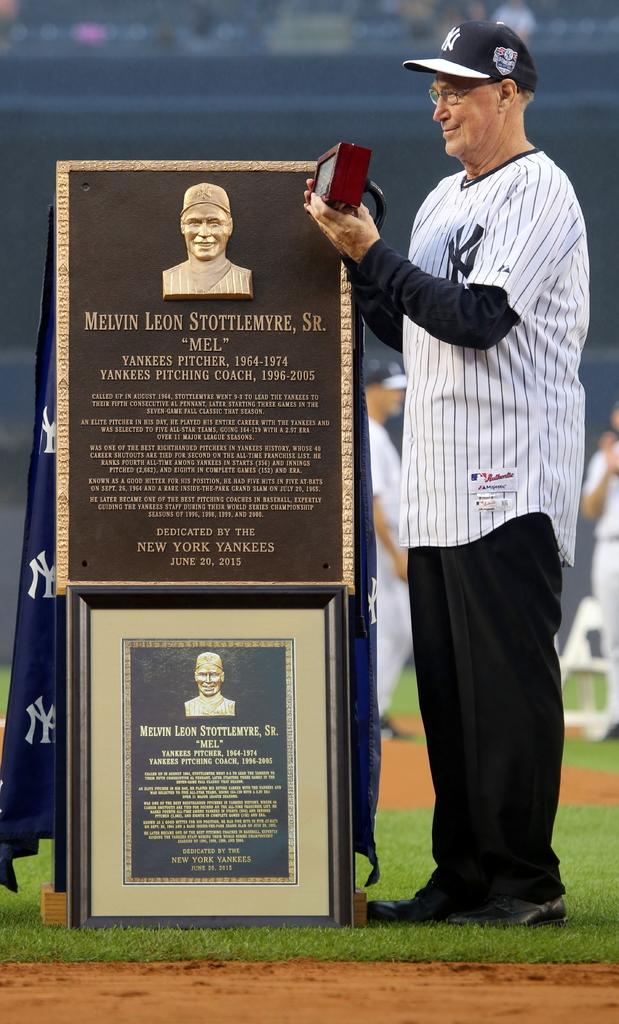<image>
Render a clear and concise summary of the photo. A baseball player accepting a award plaque with the name Melvin Leon Stottlemyer. 